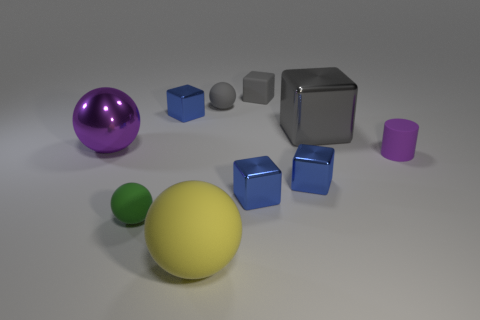Are there more cyan rubber cubes than blue blocks?
Make the answer very short. No. What number of brown matte spheres have the same size as the shiny ball?
Keep it short and to the point. 0. Are the tiny purple cylinder and the tiny gray thing in front of the rubber cube made of the same material?
Offer a terse response. Yes. Is the number of small rubber things less than the number of metallic objects?
Ensure brevity in your answer.  Yes. Is there anything else of the same color as the big rubber ball?
Provide a succinct answer. No. The small green object that is made of the same material as the large yellow sphere is what shape?
Your answer should be compact. Sphere. What number of small cubes are on the left side of the small blue metallic thing that is left of the big ball in front of the shiny ball?
Provide a succinct answer. 0. The matte thing that is in front of the big metallic cube and behind the green thing has what shape?
Offer a very short reply. Cylinder. Is the number of purple metallic balls in front of the metal sphere less than the number of big shiny blocks?
Provide a succinct answer. Yes. How many small things are either green metal spheres or blue shiny blocks?
Your answer should be very brief. 3. 